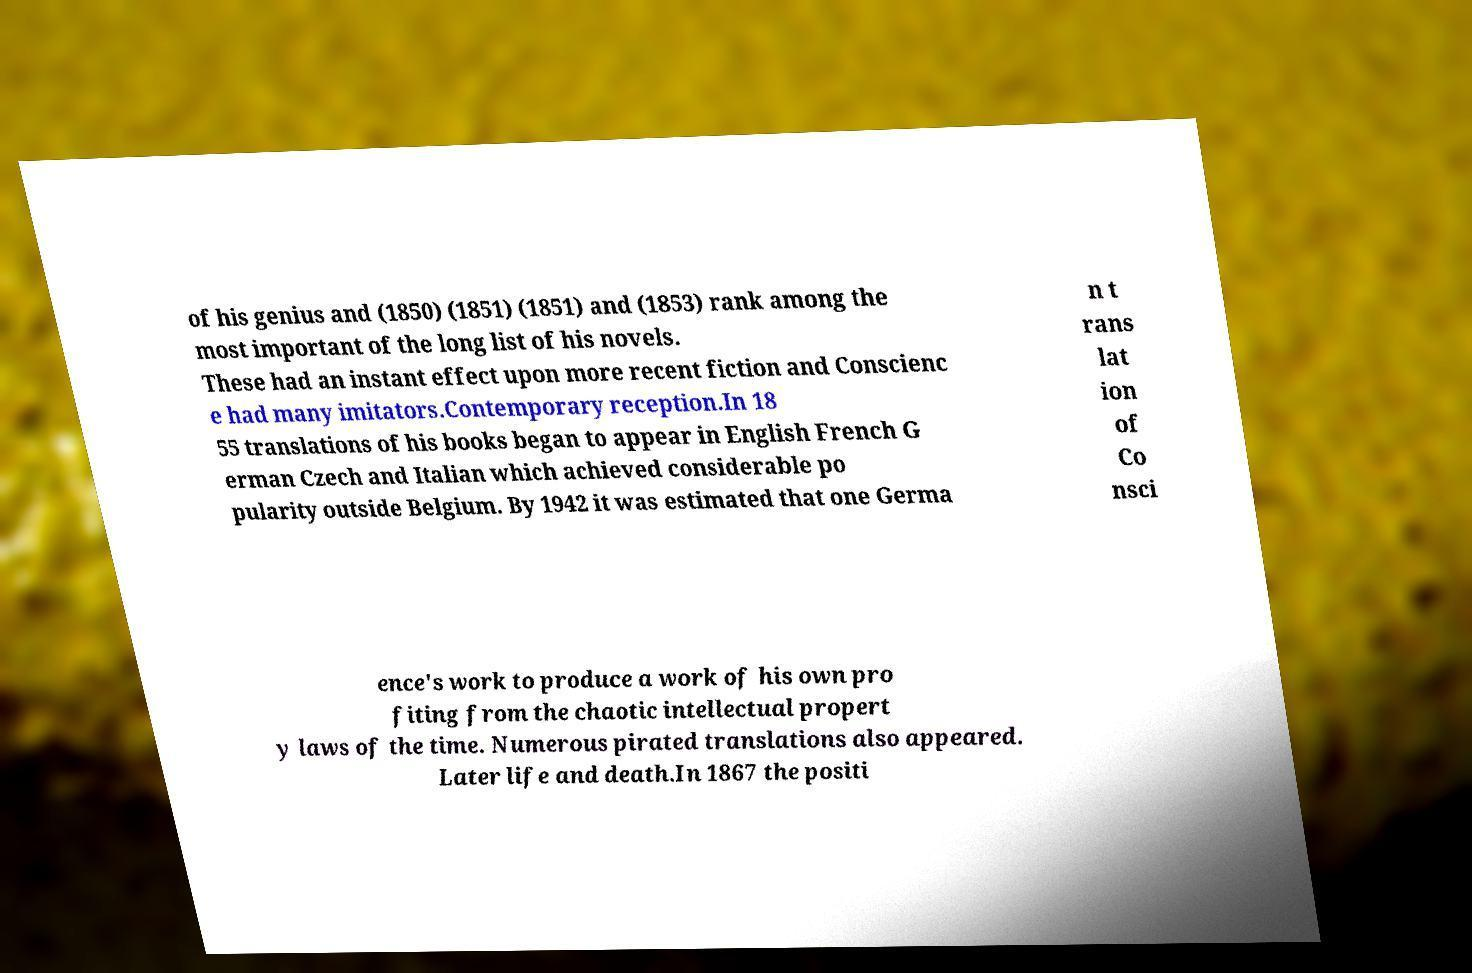Please read and relay the text visible in this image. What does it say? of his genius and (1850) (1851) (1851) and (1853) rank among the most important of the long list of his novels. These had an instant effect upon more recent fiction and Conscienc e had many imitators.Contemporary reception.In 18 55 translations of his books began to appear in English French G erman Czech and Italian which achieved considerable po pularity outside Belgium. By 1942 it was estimated that one Germa n t rans lat ion of Co nsci ence's work to produce a work of his own pro fiting from the chaotic intellectual propert y laws of the time. Numerous pirated translations also appeared. Later life and death.In 1867 the positi 